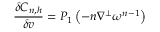Convert formula to latex. <formula><loc_0><loc_0><loc_500><loc_500>\frac { \delta C _ { n , h } } { \delta v } = P _ { 1 } \left ( - n \nabla ^ { \perp } \omega ^ { n - 1 } \right )</formula> 